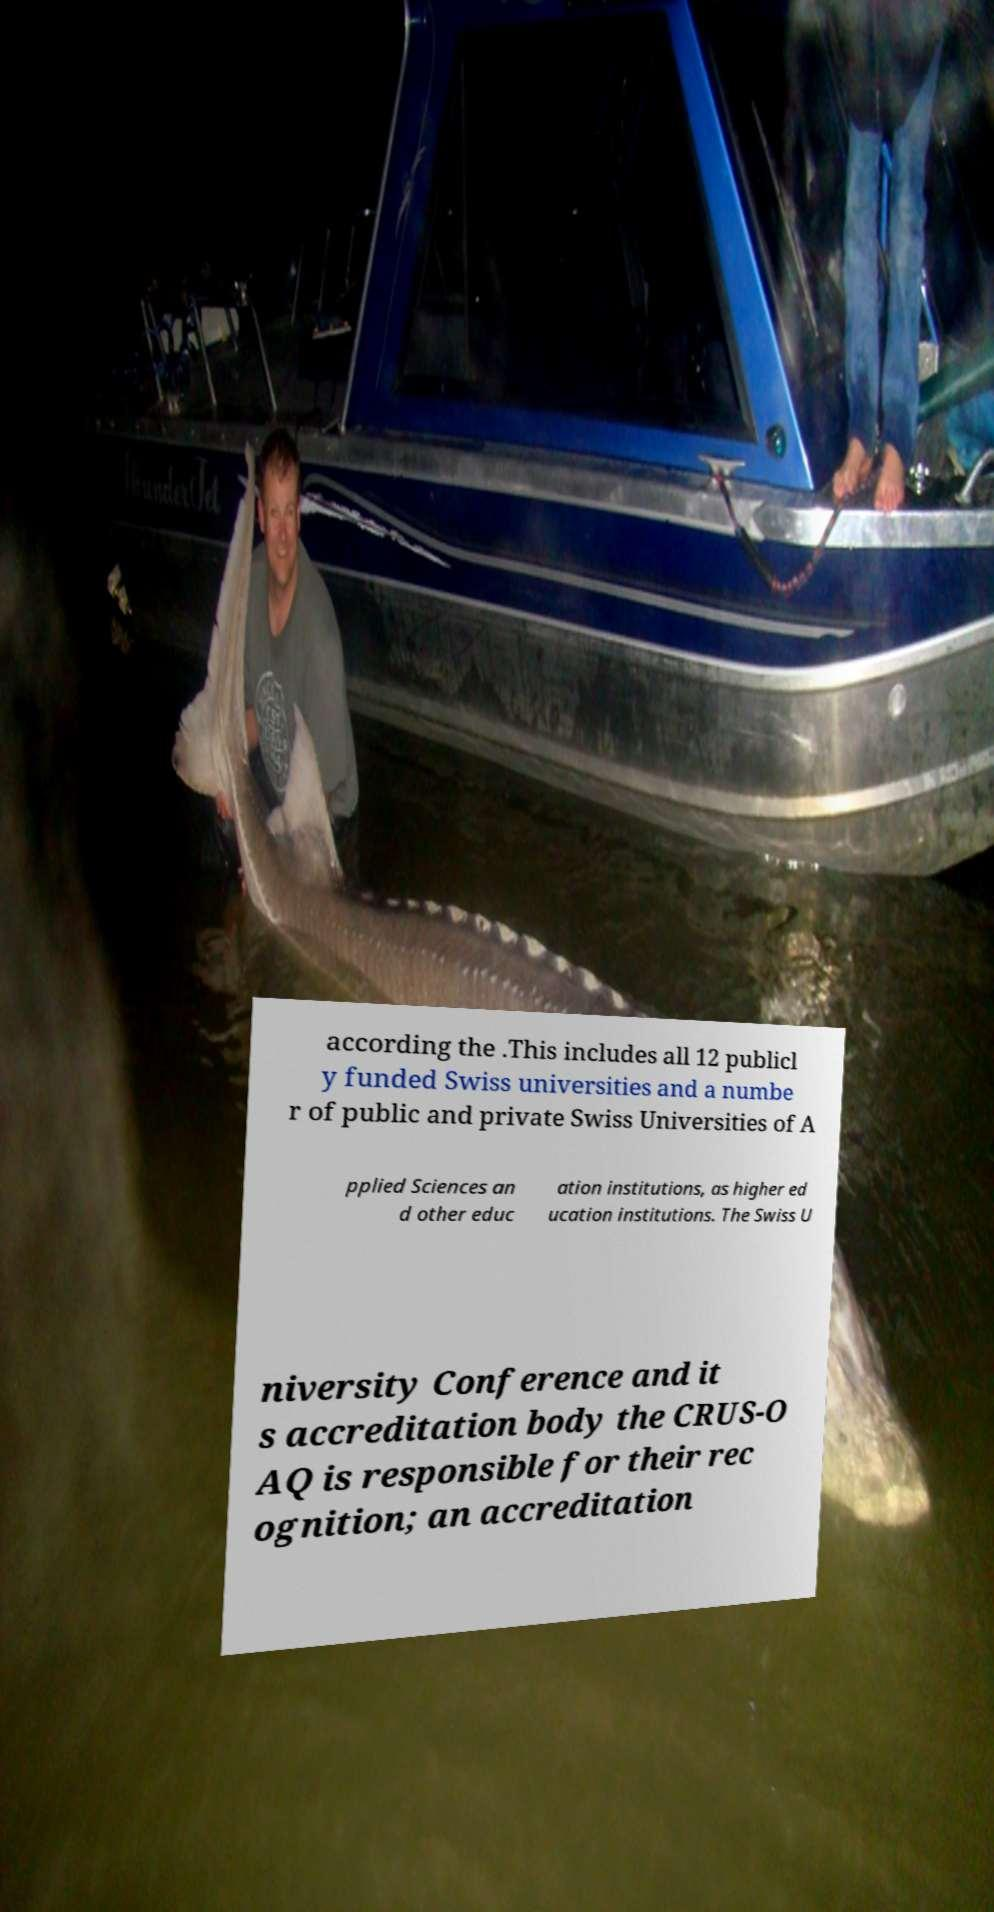Please identify and transcribe the text found in this image. according the .This includes all 12 publicl y funded Swiss universities and a numbe r of public and private Swiss Universities of A pplied Sciences an d other educ ation institutions, as higher ed ucation institutions. The Swiss U niversity Conference and it s accreditation body the CRUS-O AQ is responsible for their rec ognition; an accreditation 